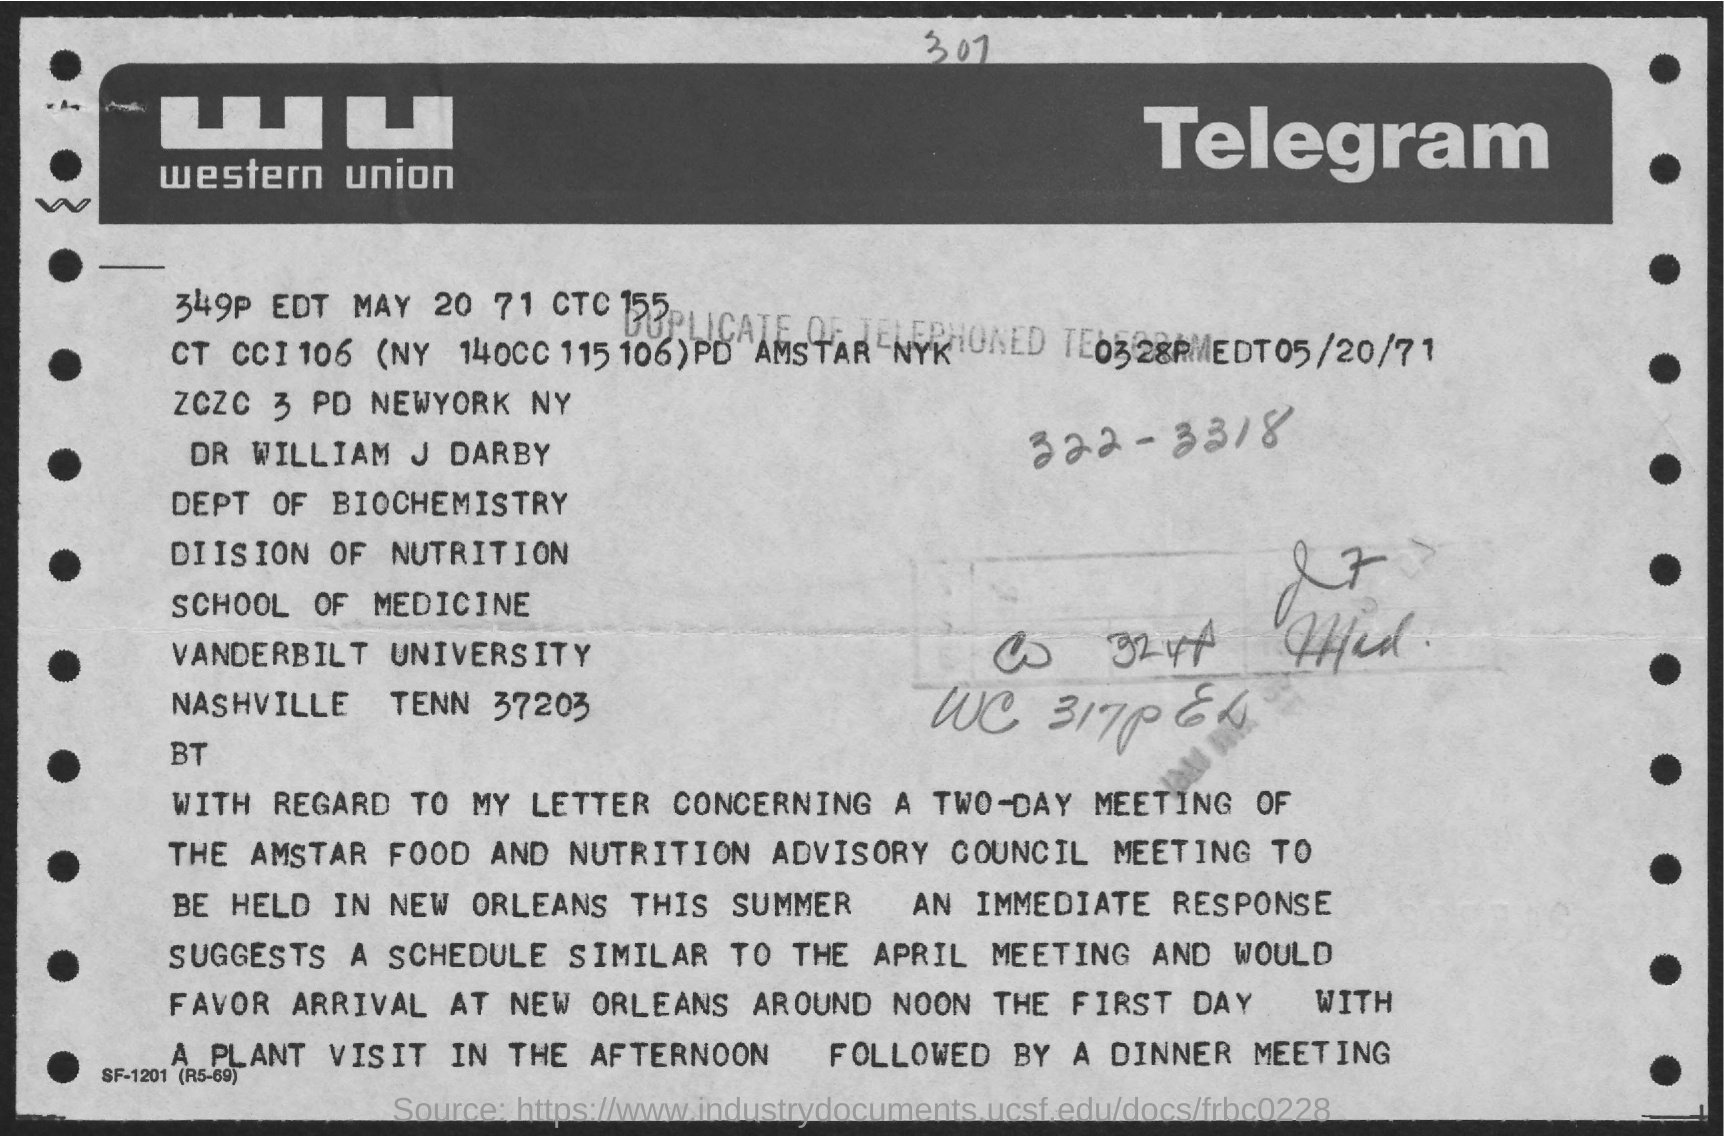To whom this letter is written ?
Keep it short and to the point. Dr William J Darby. What is the name of the university
Your answer should be very brief. Vanderbilt University. 